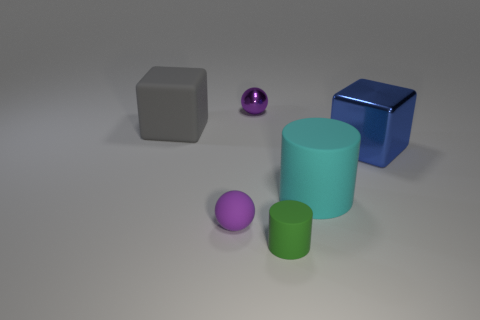What number of purple things are small shiny spheres or big rubber cylinders?
Provide a succinct answer. 1. What shape is the big rubber thing that is to the right of the tiny purple thing in front of the shiny block?
Keep it short and to the point. Cylinder. There is a sphere that is behind the large blue thing; is its size the same as the purple sphere that is in front of the gray matte thing?
Keep it short and to the point. Yes. Is there another big block that has the same material as the gray block?
Your response must be concise. No. Is there a green rubber thing that is behind the small rubber object to the left of the green thing that is to the right of the tiny purple metallic object?
Give a very brief answer. No. There is a gray block; are there any blue metal things on the left side of it?
Provide a short and direct response. No. There is a cube that is in front of the large gray matte block; how many objects are in front of it?
Your response must be concise. 3. There is a cyan matte cylinder; is its size the same as the block behind the large metallic object?
Offer a terse response. Yes. Is there a thing of the same color as the small rubber ball?
Ensure brevity in your answer.  Yes. There is a block that is made of the same material as the big cyan thing; what is its size?
Give a very brief answer. Large. 